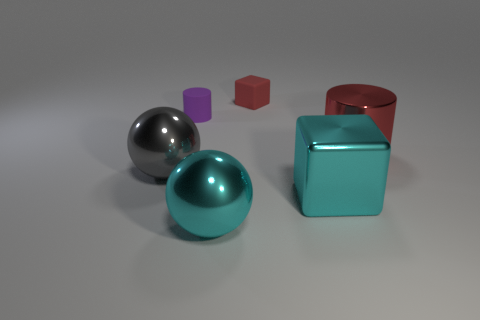Add 1 purple cylinders. How many objects exist? 7 Subtract all cylinders. How many objects are left? 4 Add 6 big gray objects. How many big gray objects are left? 7 Add 2 big yellow balls. How many big yellow balls exist? 2 Subtract 0 gray blocks. How many objects are left? 6 Subtract all blue matte objects. Subtract all red cubes. How many objects are left? 5 